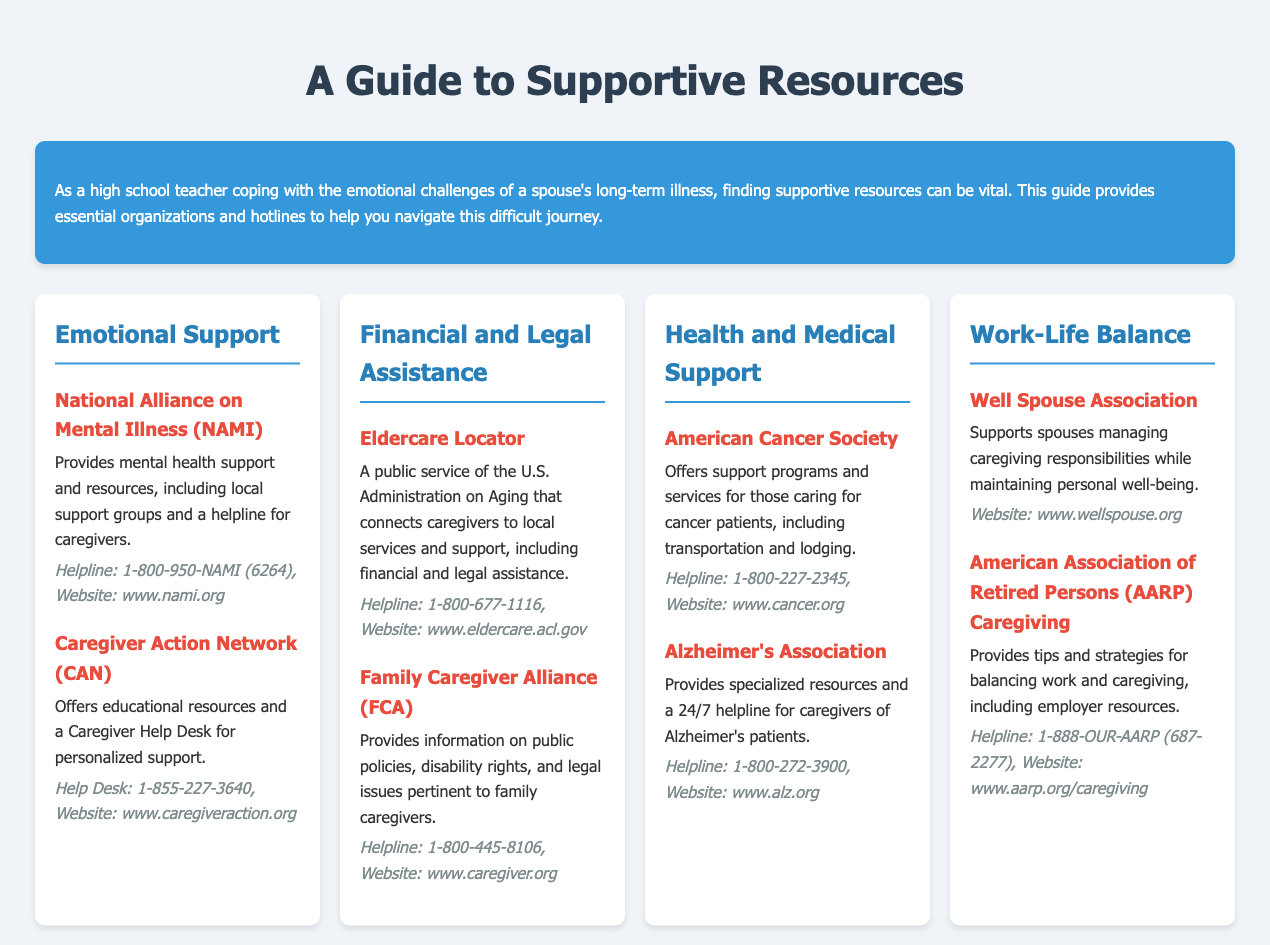What is the first resource listed under Emotional Support? The first resource under Emotional Support is the National Alliance on Mental Illness (NAMI).
Answer: National Alliance on Mental Illness (NAMI) What helpline can you call for personalized caregiver support? The helpline for personalized caregiver support is from the Caregiver Action Network (CAN).
Answer: 1-855-227-3640 What type of assistance does Eldercare Locator provide? Eldercare Locator connects caregivers to local services and support, including financial and legal assistance.
Answer: Financial and legal assistance What organization offers support programs for cancer caregivers? The organization that offers support programs for cancer caregivers is the American Cancer Society.
Answer: American Cancer Society Which hotline is available for Alzheimer's caregiver support? The hotline available for Alzheimer's caregiver support is 1-800-272-3900.
Answer: 1-800-272-3900 How does the Well Spouse Association assist caregivers? The Well Spouse Association supports spouses managing caregiving responsibilities while maintaining personal well-being.
Answer: Personal well-being What organization helps balance work and caregiving? The organization that provides tips and strategies for balancing work and caregiving is the American Association of Retired Persons (AARP) Caregiving.
Answer: American Association of Retired Persons (AARP) Caregiving What is the main purpose of the guide? The main purpose of the guide is to provide essential organizations and hotlines to help navigate the caregiving journey.
Answer: Provide essential organizations and hotlines 